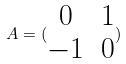Convert formula to latex. <formula><loc_0><loc_0><loc_500><loc_500>A = ( \begin{matrix} 0 & 1 \\ - 1 & 0 \end{matrix} )</formula> 